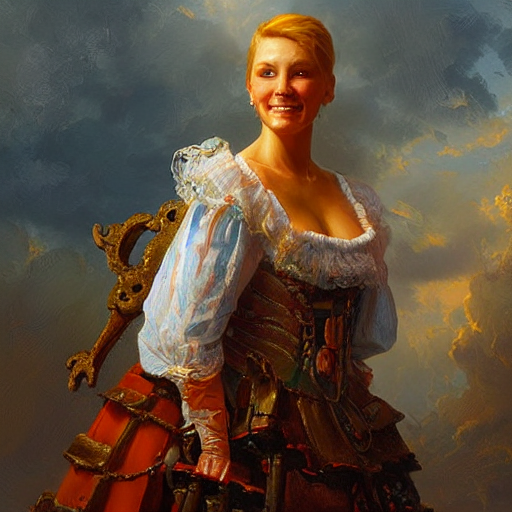Can you describe the emotion conveyed by the person's expression in the image? The person in the image appears to convey a sense of contentment and confidence, with a warm smile and bright eyes that welcome the viewer into the scene. 